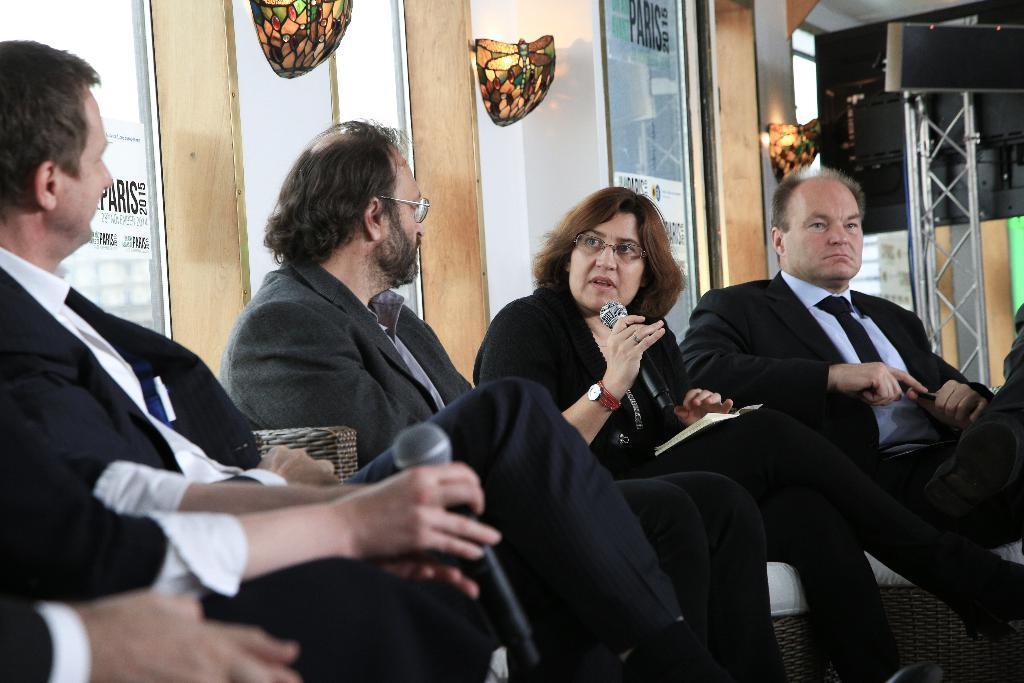Describe this image in one or two sentences. In the picture we can see three men and a woman sitting on the chairs near the wall and they are in blazers, ties and woman is talking in the microphone holding it and one man is also holding a microphone and behind them, we can see a wall with glass and some wooden frames in it and beside it we can see a wall with a lamp. 